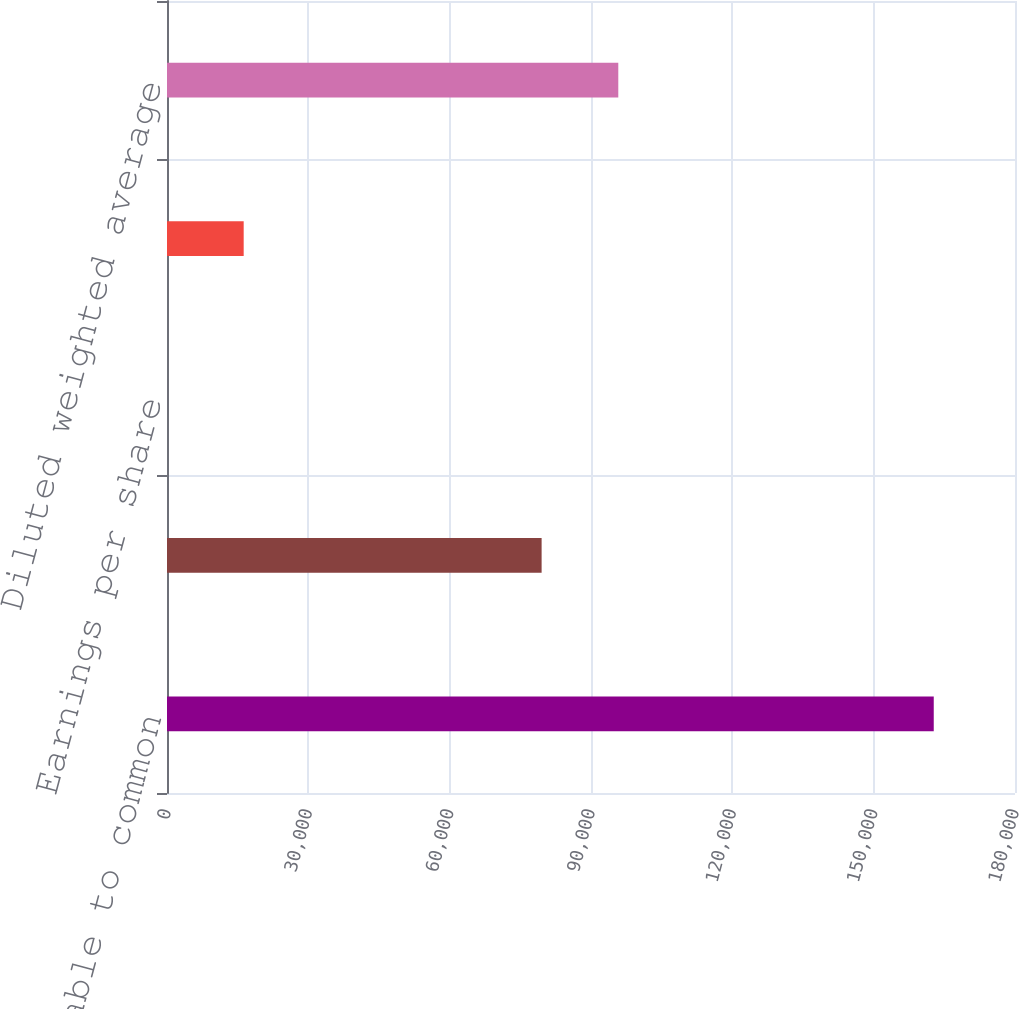<chart> <loc_0><loc_0><loc_500><loc_500><bar_chart><fcel>Net income available to common<fcel>Basic weighted average shares<fcel>Earnings per share<fcel>Plus dilutive effect of stock<fcel>Diluted weighted average<nl><fcel>162754<fcel>79518<fcel>2.05<fcel>16277.2<fcel>95793.2<nl></chart> 